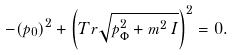<formula> <loc_0><loc_0><loc_500><loc_500>- ( p _ { 0 } ) ^ { 2 } + \left ( T r \sqrt { p _ { \Phi } ^ { 2 } + m ^ { 2 } \, { I } } \right ) ^ { 2 } = 0 .</formula> 